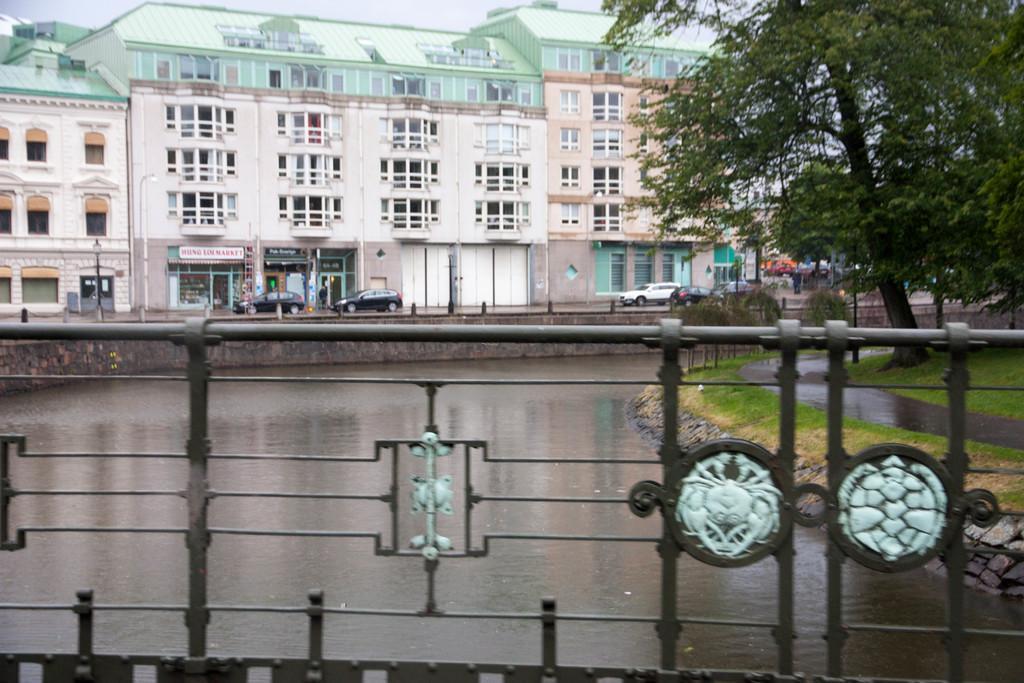Can you describe this image briefly? In the image we can see there is water and the ground is covered with grass. There are trees and there are cars parked on the road. Behind there are buildings. 